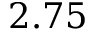Convert formula to latex. <formula><loc_0><loc_0><loc_500><loc_500>2 . 7 5</formula> 